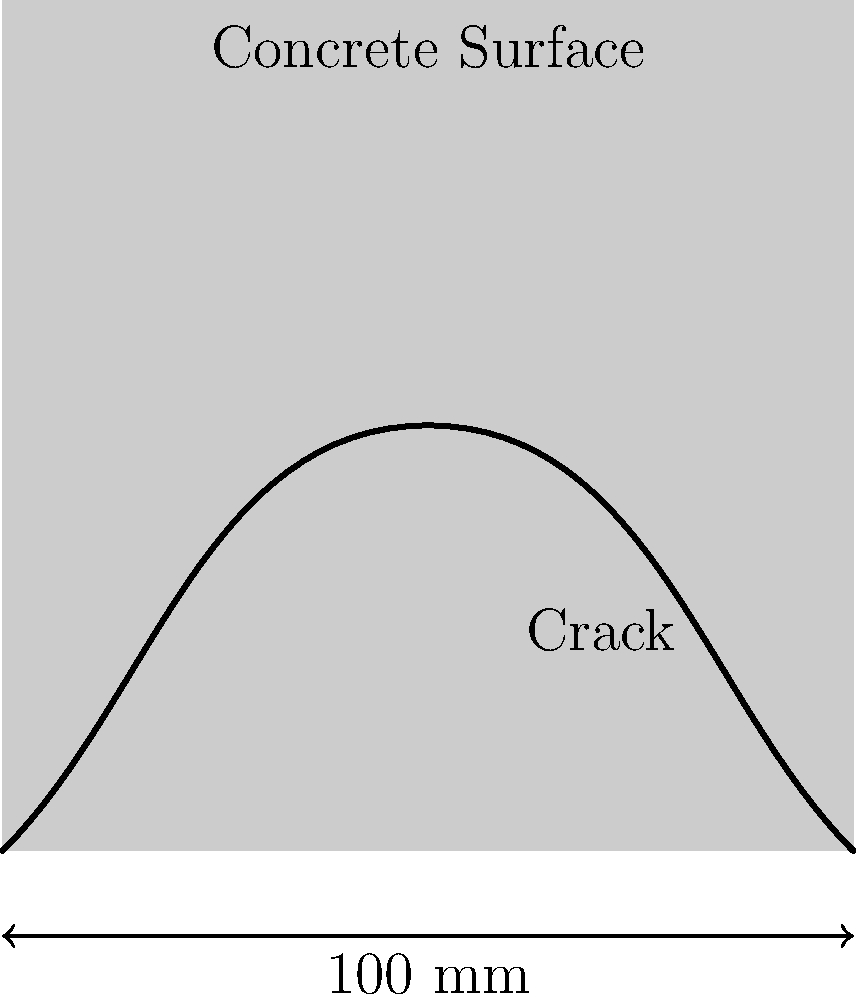In deep learning-based crack detection for concrete surfaces, what feature extraction technique would be most effective for identifying the crack shown in the image, and why? To effectively detect cracks in concrete surfaces using deep learning, we need to consider the following steps:

1. Image preprocessing:
   - Enhance contrast to make cracks more visible
   - Apply noise reduction techniques to remove artifacts

2. Feature extraction:
   - Convolutional Neural Networks (CNNs) are ideal for this task
   - CNNs can automatically learn relevant features from the image

3. Key features for crack detection:
   - Edge detection: Cracks often have distinct edges
   - Texture analysis: Concrete texture differs from crack texture
   - Shape analysis: Cracks typically have elongated, irregular shapes

4. CNN architecture:
   - Use multiple convolutional layers to capture different levels of features
   - Include pooling layers to reduce spatial dimensions and capture invariance
   - Add fully connected layers for classification

5. Transfer learning:
   - Utilize pre-trained models (e.g., VGG, ResNet) and fine-tune for crack detection
   - This approach can improve performance with limited training data

6. Data augmentation:
   - Apply techniques like rotation, flipping, and scaling to increase dataset diversity
   - This helps the model generalize better to various crack orientations and sizes

7. Post-processing:
   - Apply morphological operations to refine crack detection results
   - Use connected component analysis to identify continuous crack segments

Considering these factors, Convolutional Neural Networks (CNNs) would be the most effective feature extraction technique for identifying the crack shown in the image. CNNs can automatically learn hierarchical features, from low-level edges to high-level crack patterns, making them well-suited for detecting the complex, irregular shapes of cracks in concrete surfaces.
Answer: Convolutional Neural Networks (CNNs) 